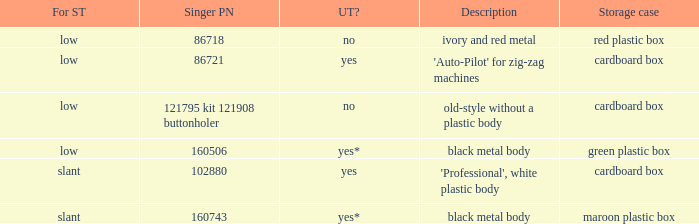What are all the different descriptions for the buttonholer with cardboard box for storage and a low shank type? 'Auto-Pilot' for zig-zag machines, old-style without a plastic body. 